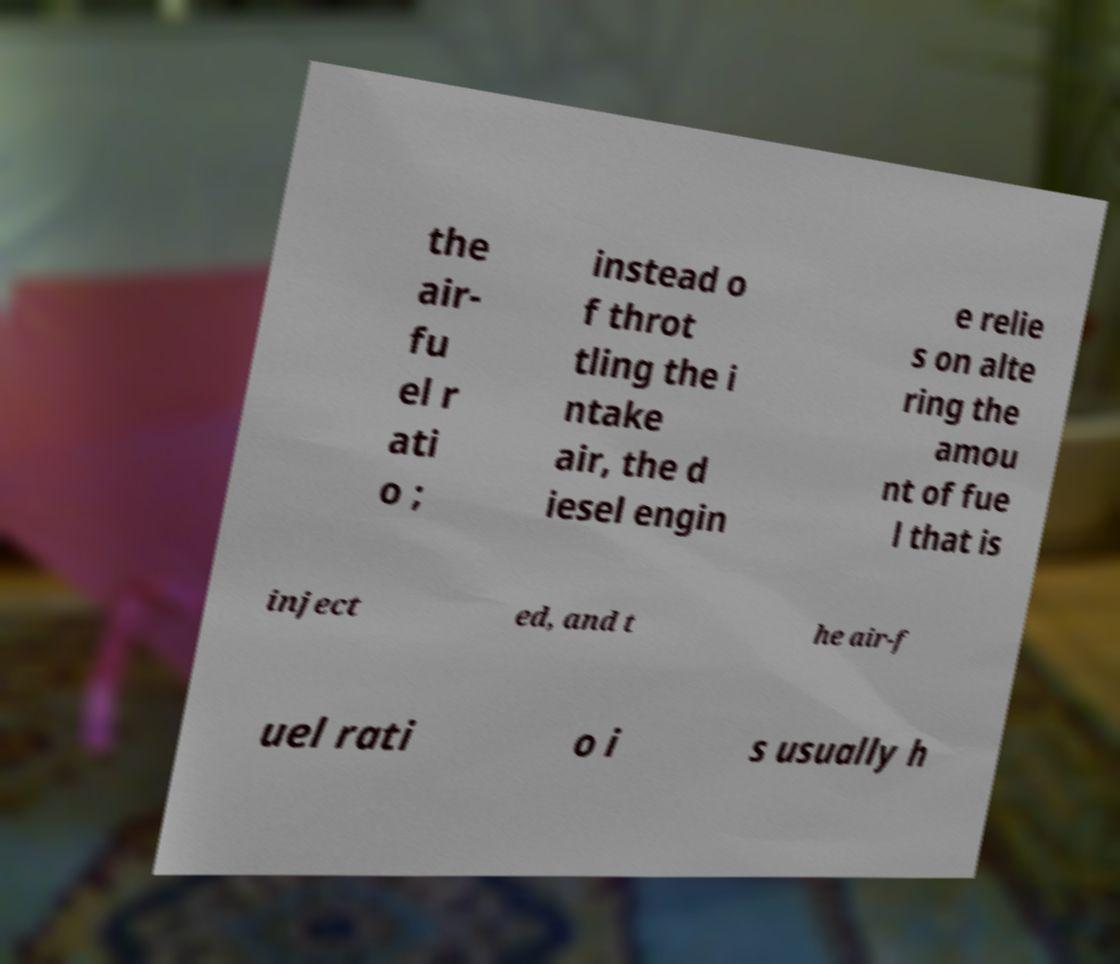I need the written content from this picture converted into text. Can you do that? the air- fu el r ati o ; instead o f throt tling the i ntake air, the d iesel engin e relie s on alte ring the amou nt of fue l that is inject ed, and t he air-f uel rati o i s usually h 